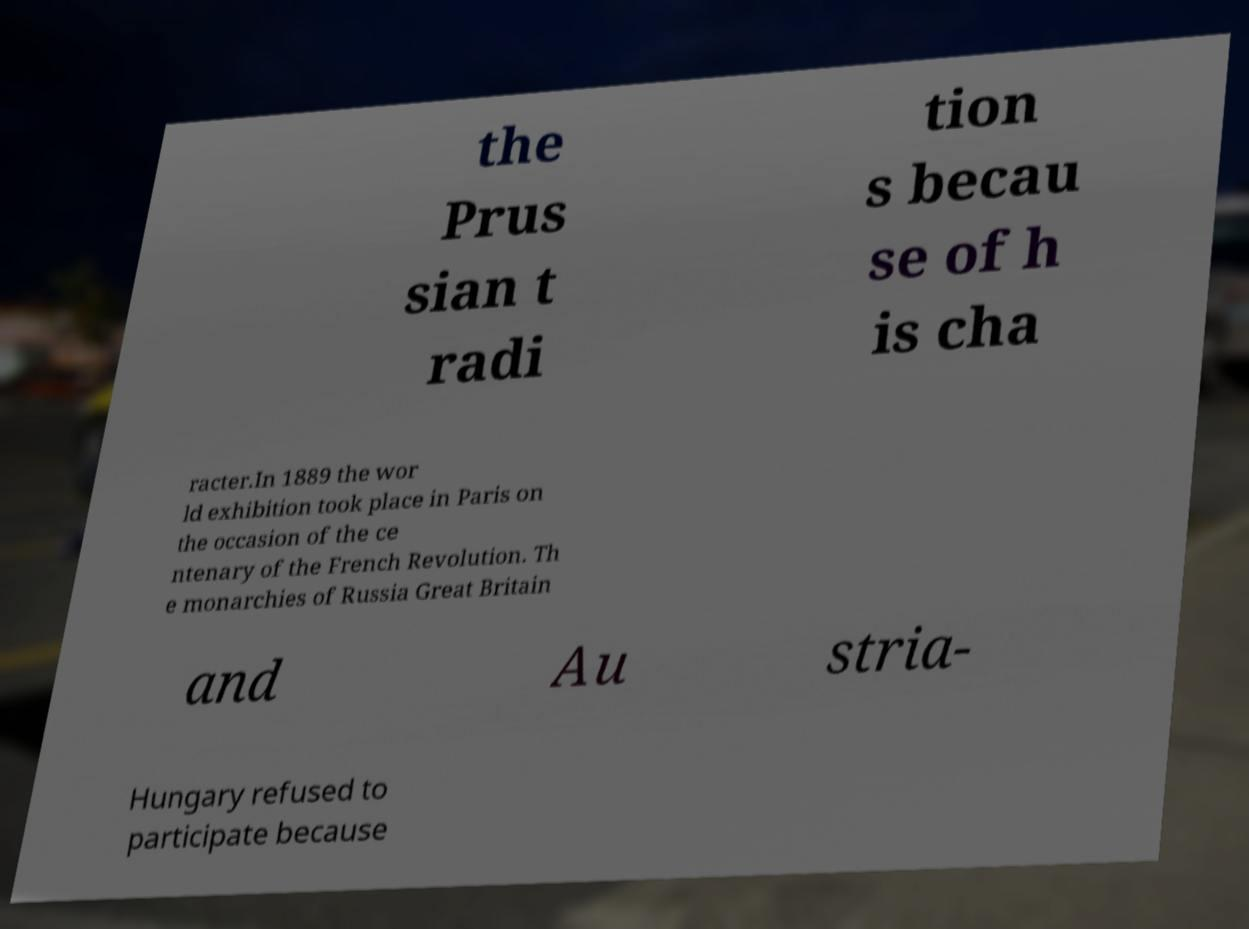Please read and relay the text visible in this image. What does it say? the Prus sian t radi tion s becau se of h is cha racter.In 1889 the wor ld exhibition took place in Paris on the occasion of the ce ntenary of the French Revolution. Th e monarchies of Russia Great Britain and Au stria- Hungary refused to participate because 